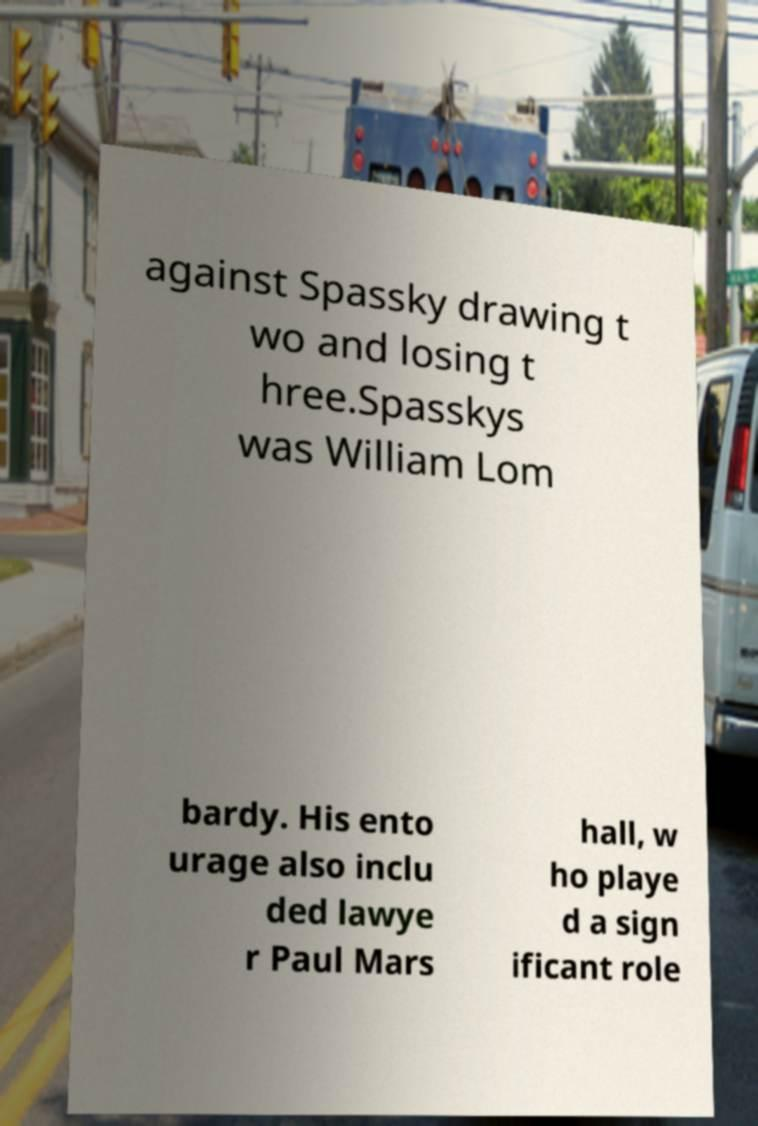There's text embedded in this image that I need extracted. Can you transcribe it verbatim? against Spassky drawing t wo and losing t hree.Spasskys was William Lom bardy. His ento urage also inclu ded lawye r Paul Mars hall, w ho playe d a sign ificant role 